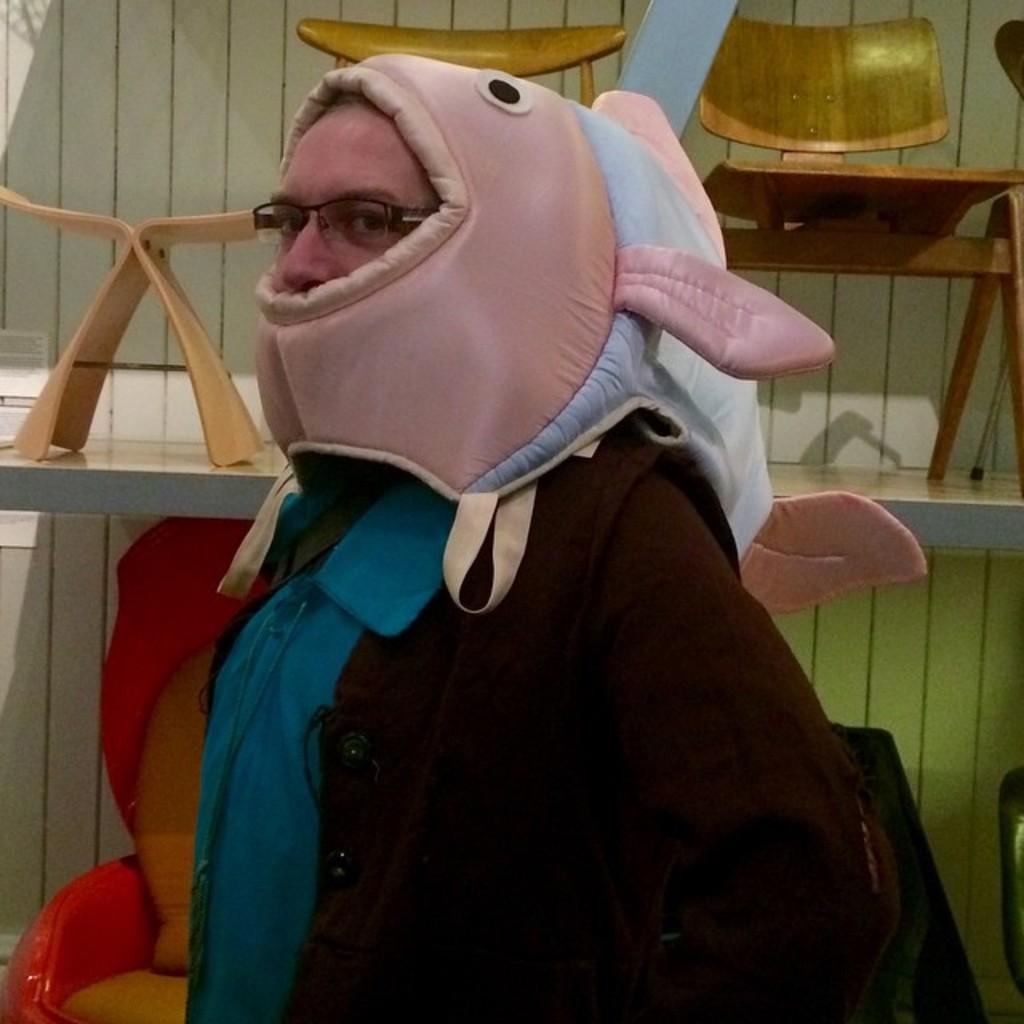Please provide a concise description of this image. In this image there is a person. There are chairs in the background. There is a white color wall. 